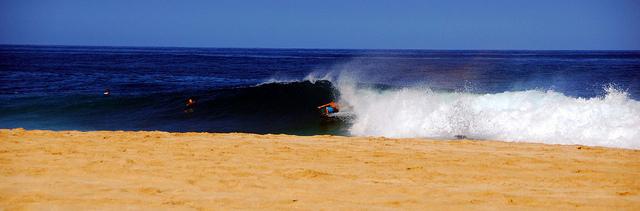Is anybody surfing?
Give a very brief answer. Yes. What kind of tide is coming in right now?
Short answer required. High. Which direction is the wave crashing?
Be succinct. Left. 